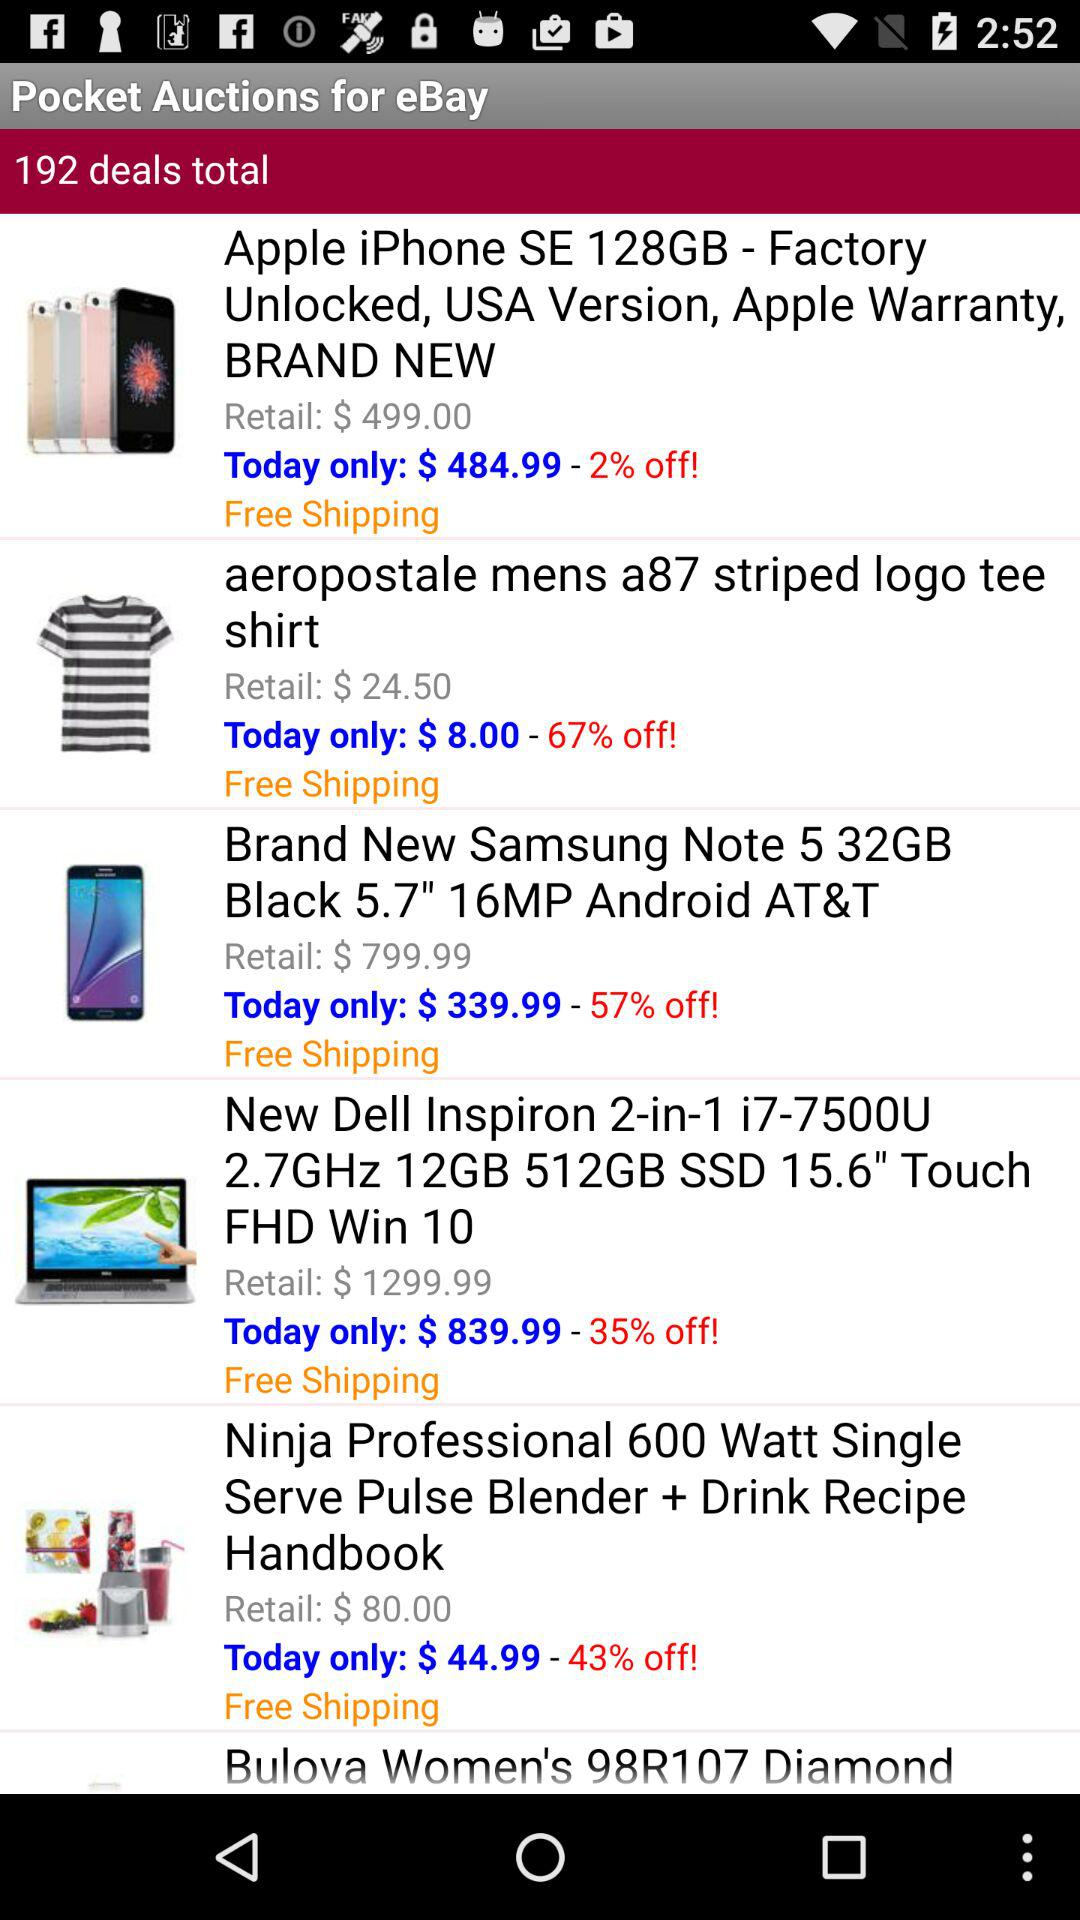How much is the discount on the "New Dell Inspiron 2-in-1 i7-7500U 2.7GHz 12GB"? The discount on the "New Dell Inspiron 2-in-1 i7-7500U 2.7GHz 12GB" is 35%. 